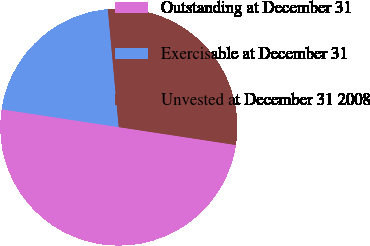<chart> <loc_0><loc_0><loc_500><loc_500><pie_chart><fcel>Outstanding at December 31<fcel>Exercisable at December 31<fcel>Unvested at December 31 2008<nl><fcel>50.0%<fcel>21.12%<fcel>28.88%<nl></chart> 